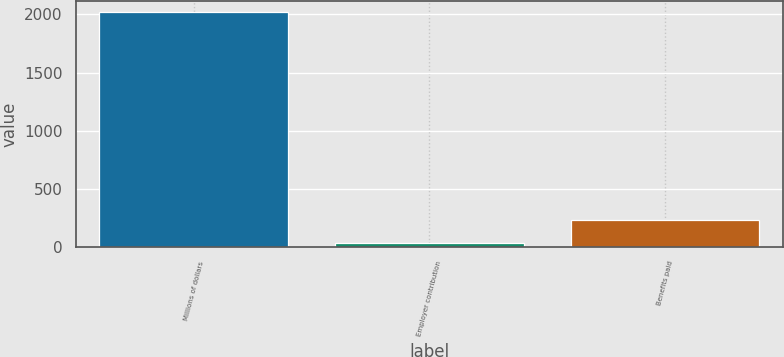Convert chart. <chart><loc_0><loc_0><loc_500><loc_500><bar_chart><fcel>Millions of dollars<fcel>Employer contribution<fcel>Benefits paid<nl><fcel>2017<fcel>40<fcel>237.7<nl></chart> 